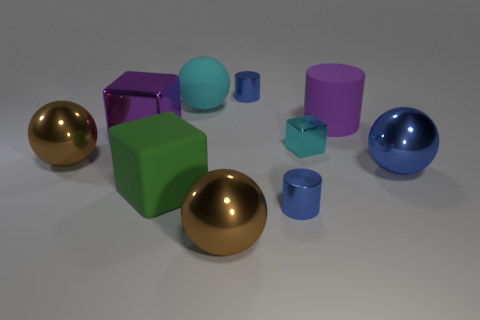There is a big matte sphere; is its color the same as the small cylinder behind the large green object?
Make the answer very short. No. Do the metal cylinder that is in front of the big cylinder and the big rubber cube have the same color?
Provide a succinct answer. No. What number of objects are either matte cylinders or large shiny things that are behind the small cyan metal block?
Your answer should be compact. 2. What is the material of the cylinder that is behind the big blue ball and in front of the big cyan thing?
Keep it short and to the point. Rubber. There is a tiny blue object in front of the big purple rubber cylinder; what material is it?
Make the answer very short. Metal. There is a cylinder that is made of the same material as the green thing; what color is it?
Offer a terse response. Purple. There is a small cyan metallic object; does it have the same shape as the large matte object that is in front of the large blue ball?
Your response must be concise. Yes. Are there any brown spheres behind the purple cylinder?
Provide a succinct answer. No. There is a thing that is the same color as the small cube; what material is it?
Your answer should be compact. Rubber. There is a cyan matte object; does it have the same size as the blue shiny sphere to the right of the big green block?
Your response must be concise. Yes. 